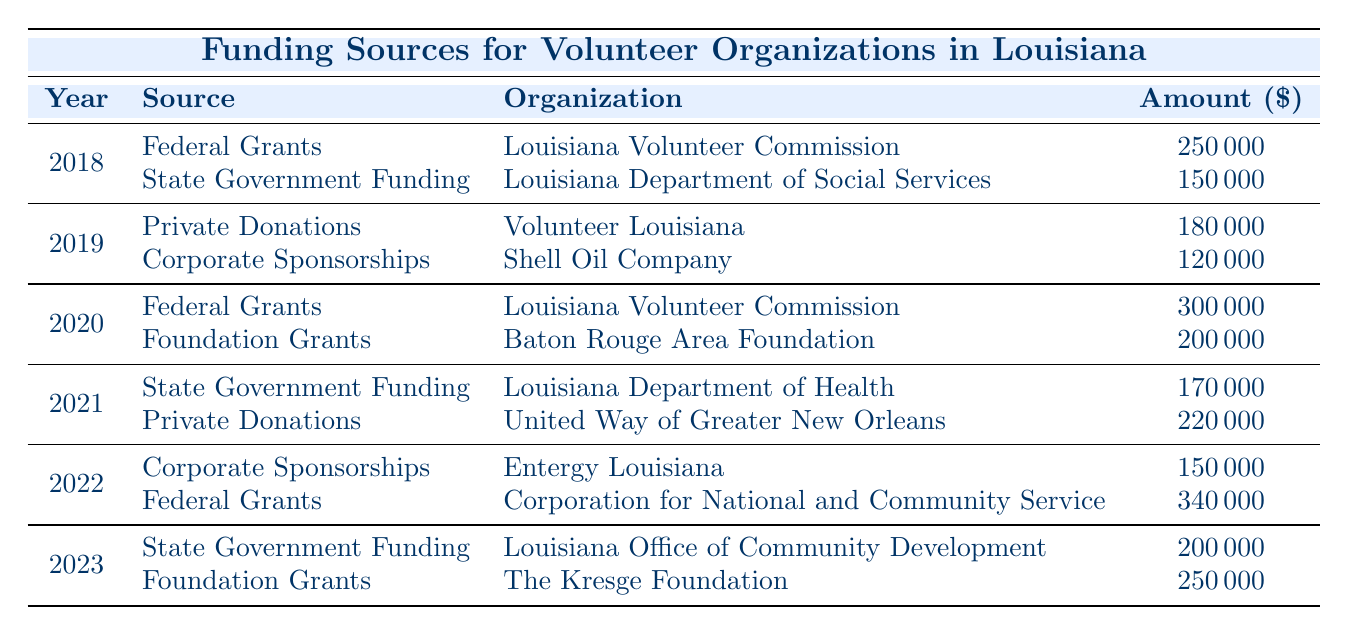What was the total amount allocated from Federal Grants in 2018? In 2018, the Federal Grants allocated $250,000 to the Louisiana Volunteer Commission. Therefore, the total amount from this source is simply the amount stated.
Answer: 250000 Which organization received the highest allocation in 2022? In 2022, the Corporation for National and Community Service received $340,000, which is higher than the $150,000 received by Entergy Louisiana. Thus, Corporation for National and Community Service had the highest allocation that year.
Answer: Corporation for National and Community Service What was the total amount allocated to State Government Funding over the five years? The amounts allocated to State Government Funding are as follows: $150,000 in 2018, $170,000 in 2021, and $200,000 in 2023. Adding these amounts together: 150000 + 170000 + 200000 = 520000. Thus, the total allocation for State Government Funding is $520,000.
Answer: 520000 Was there an increase in allocation from Corporate Sponsorships from 2019 to 2022? In 2019, the Corporate Sponsorships allocation was $120,000, while in 2022 it was $150,000. Since $150,000 is greater than $120,000, it indicates an increase in the allocation from Corporate Sponsorships between those years.
Answer: Yes What was the average amount allocated to Private Donations across the years? Private Donations were allocated in 2019 with $180,000 and in 2021 with $220,000. To find the average, sum these allocations: 180000 + 220000 = 400000, and divide by the number of instances (2): 400000 / 2 = 200000. Thus, the average amount allocated to Private Donations is $200,000.
Answer: 200000 